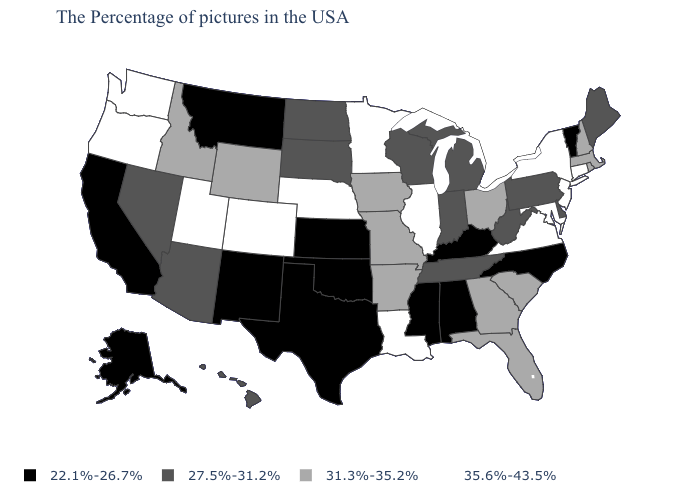Name the states that have a value in the range 31.3%-35.2%?
Quick response, please. Massachusetts, Rhode Island, New Hampshire, South Carolina, Ohio, Florida, Georgia, Missouri, Arkansas, Iowa, Wyoming, Idaho. What is the value of Louisiana?
Be succinct. 35.6%-43.5%. How many symbols are there in the legend?
Give a very brief answer. 4. What is the value of Arizona?
Concise answer only. 27.5%-31.2%. Name the states that have a value in the range 35.6%-43.5%?
Give a very brief answer. Connecticut, New York, New Jersey, Maryland, Virginia, Illinois, Louisiana, Minnesota, Nebraska, Colorado, Utah, Washington, Oregon. Name the states that have a value in the range 22.1%-26.7%?
Be succinct. Vermont, North Carolina, Kentucky, Alabama, Mississippi, Kansas, Oklahoma, Texas, New Mexico, Montana, California, Alaska. Name the states that have a value in the range 35.6%-43.5%?
Give a very brief answer. Connecticut, New York, New Jersey, Maryland, Virginia, Illinois, Louisiana, Minnesota, Nebraska, Colorado, Utah, Washington, Oregon. What is the value of Colorado?
Keep it brief. 35.6%-43.5%. Does Washington have a higher value than Alabama?
Concise answer only. Yes. What is the value of Wyoming?
Answer briefly. 31.3%-35.2%. What is the lowest value in the MidWest?
Keep it brief. 22.1%-26.7%. Name the states that have a value in the range 27.5%-31.2%?
Quick response, please. Maine, Delaware, Pennsylvania, West Virginia, Michigan, Indiana, Tennessee, Wisconsin, South Dakota, North Dakota, Arizona, Nevada, Hawaii. What is the value of Florida?
Short answer required. 31.3%-35.2%. What is the lowest value in the USA?
Give a very brief answer. 22.1%-26.7%. 